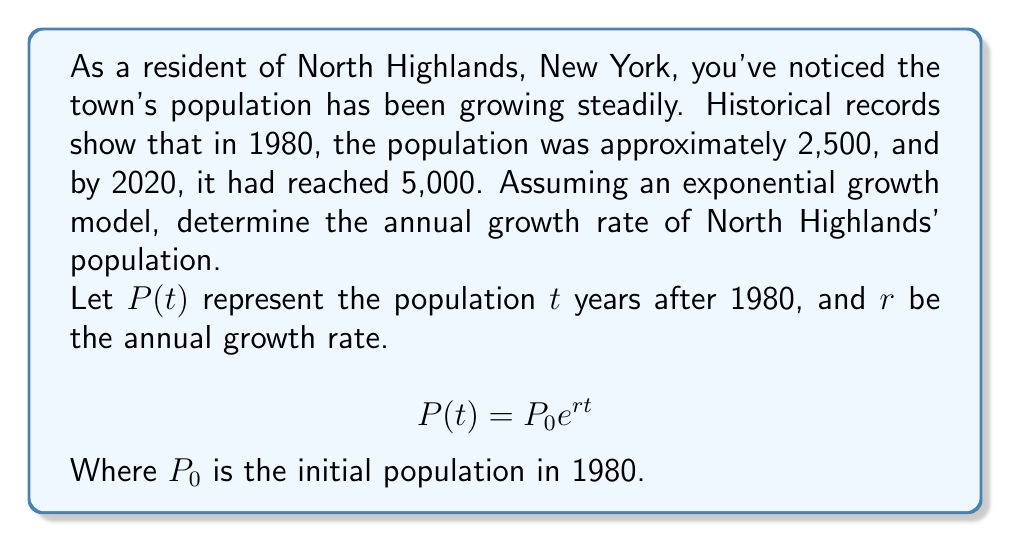Show me your answer to this math problem. Let's solve this step-by-step:

1) We know two points on our exponential curve:
   - In 1980 (t = 0): P(0) = 2,500
   - In 2020 (t = 40): P(40) = 5,000

2) Let's use the exponential growth formula:
   $$P(t) = P_0 e^{rt}$$

3) Plug in our known values:
   $$5000 = 2500 e^{40r}$$

4) Divide both sides by 2500:
   $$2 = e^{40r}$$

5) Take the natural log of both sides:
   $$\ln(2) = 40r$$

6) Solve for r:
   $$r = \frac{\ln(2)}{40}$$

7) Calculate the value:
   $$r \approx 0.01733$$

8) Convert to a percentage:
   $$r \approx 1.733\%$$

Therefore, the annual growth rate of North Highlands' population is approximately 1.733%.
Answer: $1.733\%$ per year 